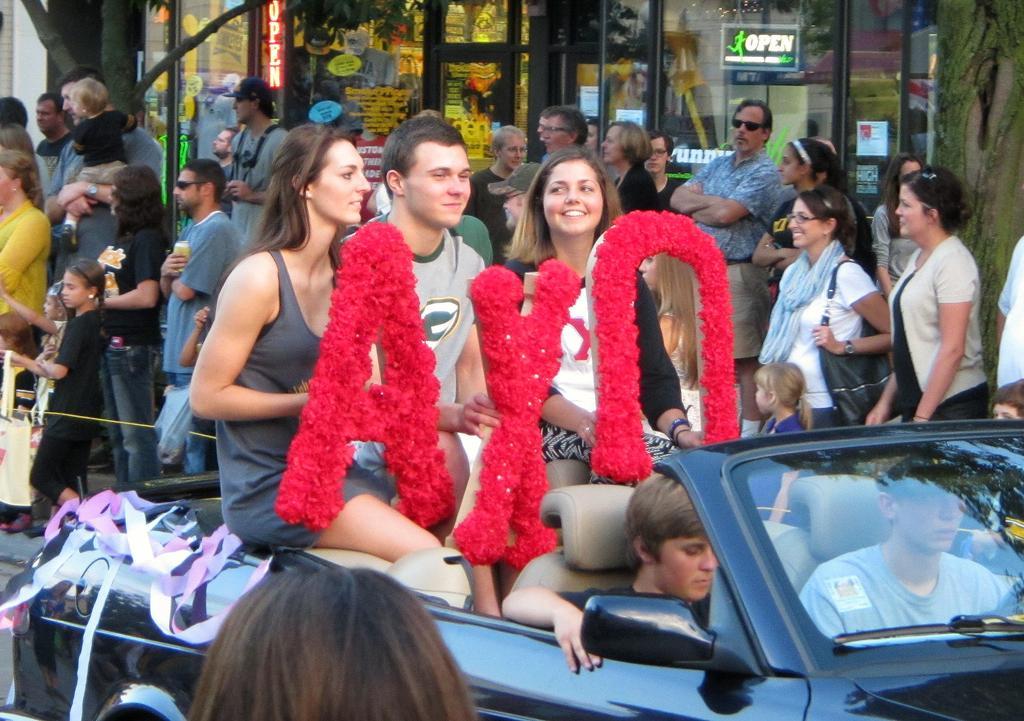In one or two sentences, can you explain what this image depicts? This picture shows few people are standing on the side and we see few people are seated in the car holding a red colour letters in their hands and we see few stores on the right and man holding a glass in his hand 